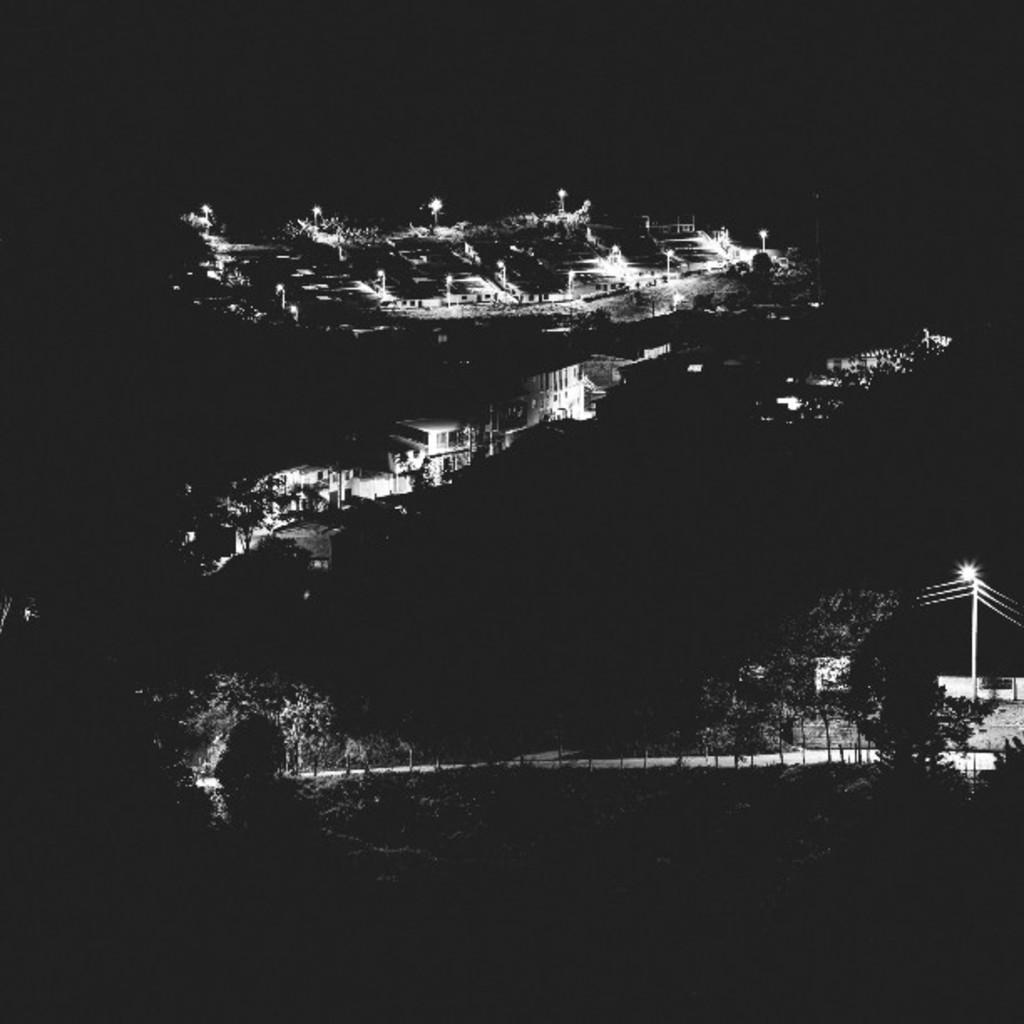What type of structures can be seen in the image? There are buildings in the image. What type of vegetation is present in the image? There are trees in the image. What type of lighting is present in the image? There are pole lights in the image. What type of disgust can be seen on the clam's face in the image? There is no clam or any indication of disgust in the image; it features buildings, trees, and pole lights. What subject is being taught in the image? There is no teaching or any indication of a subject being taught in the image. 